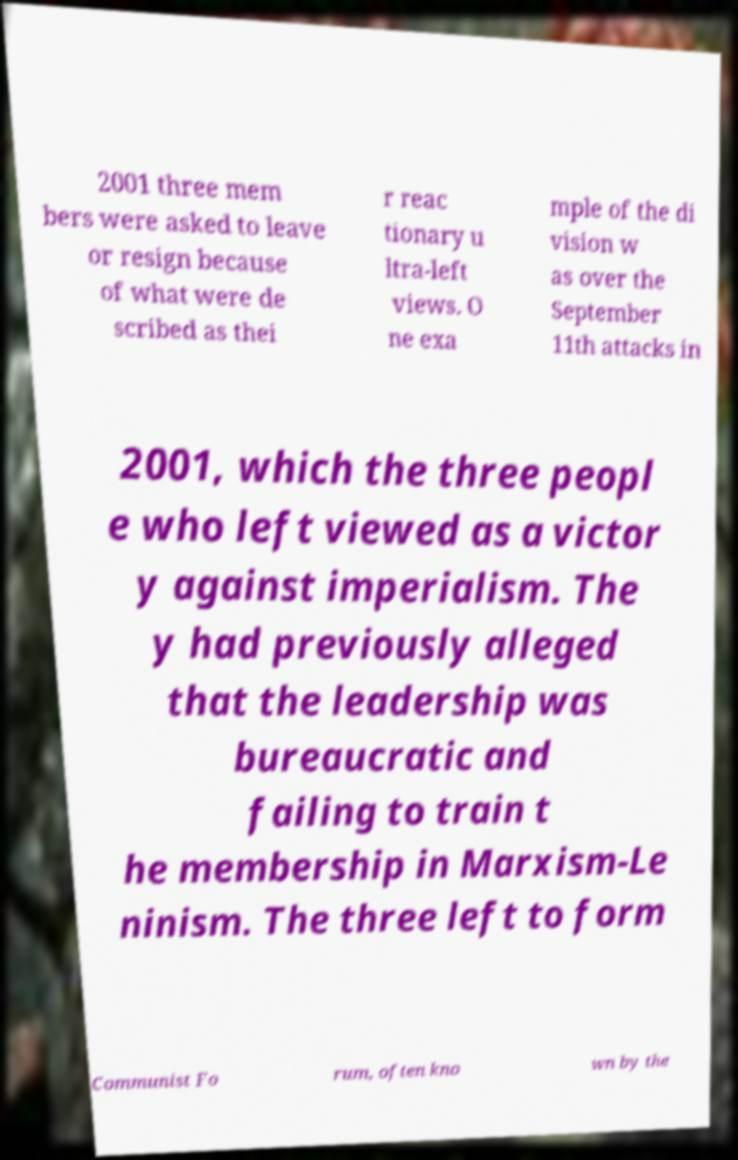What messages or text are displayed in this image? I need them in a readable, typed format. 2001 three mem bers were asked to leave or resign because of what were de scribed as thei r reac tionary u ltra-left views. O ne exa mple of the di vision w as over the September 11th attacks in 2001, which the three peopl e who left viewed as a victor y against imperialism. The y had previously alleged that the leadership was bureaucratic and failing to train t he membership in Marxism-Le ninism. The three left to form Communist Fo rum, often kno wn by the 